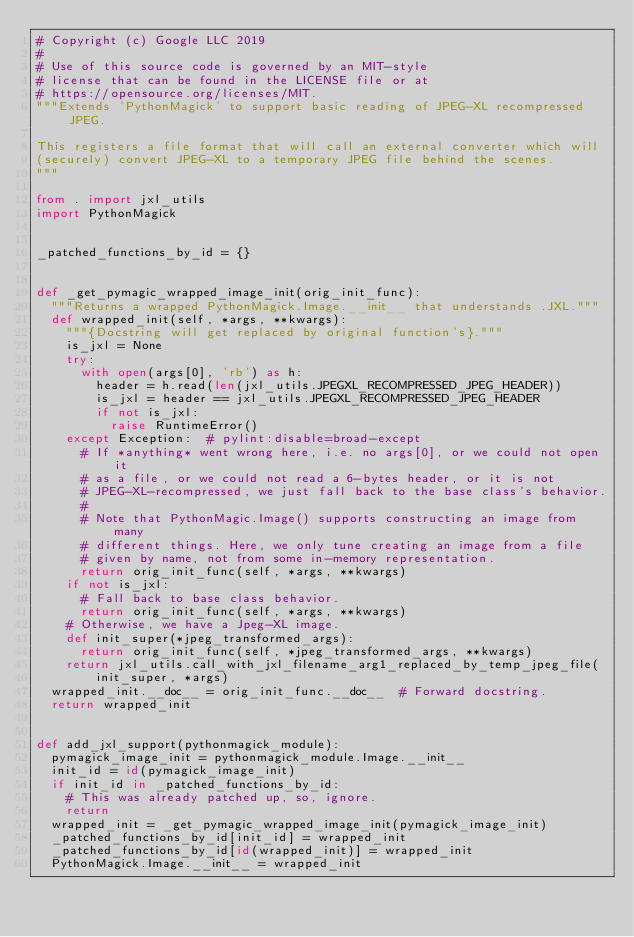Convert code to text. <code><loc_0><loc_0><loc_500><loc_500><_Python_># Copyright (c) Google LLC 2019
#
# Use of this source code is governed by an MIT-style
# license that can be found in the LICENSE file or at
# https://opensource.org/licenses/MIT.
"""Extends 'PythonMagick' to support basic reading of JPEG-XL recompressed JPEG.

This registers a file format that will call an external converter which will
(securely) convert JPEG-XL to a temporary JPEG file behind the scenes.
"""

from . import jxl_utils
import PythonMagick


_patched_functions_by_id = {}


def _get_pymagic_wrapped_image_init(orig_init_func):
  """Returns a wrapped PythonMagick.Image.__init__ that understands .JXL."""
  def wrapped_init(self, *args, **kwargs):
    """{Docstring will get replaced by original function's}."""
    is_jxl = None
    try:
      with open(args[0], 'rb') as h:
        header = h.read(len(jxl_utils.JPEGXL_RECOMPRESSED_JPEG_HEADER))
        is_jxl = header == jxl_utils.JPEGXL_RECOMPRESSED_JPEG_HEADER
        if not is_jxl:
          raise RuntimeError()
    except Exception:  # pylint:disable=broad-except
      # If *anything* went wrong here, i.e. no args[0], or we could not open it
      # as a file, or we could not read a 6-bytes header, or it is not
      # JPEG-XL-recompressed, we just fall back to the base class's behavior.
      #
      # Note that PythonMagic.Image() supports constructing an image from many
      # different things. Here, we only tune creating an image from a file
      # given by name, not from some in-memory representation.
      return orig_init_func(self, *args, **kwargs)
    if not is_jxl:
      # Fall back to base class behavior.
      return orig_init_func(self, *args, **kwargs)
    # Otherwise, we have a Jpeg-XL image.
    def init_super(*jpeg_transformed_args):
      return orig_init_func(self, *jpeg_transformed_args, **kwargs)
    return jxl_utils.call_with_jxl_filename_arg1_replaced_by_temp_jpeg_file(
        init_super, *args)
  wrapped_init.__doc__ = orig_init_func.__doc__  # Forward docstring.
  return wrapped_init


def add_jxl_support(pythonmagick_module):
  pymagick_image_init = pythonmagick_module.Image.__init__
  init_id = id(pymagick_image_init)
  if init_id in _patched_functions_by_id:
    # This was already patched up, so, ignore.
    return
  wrapped_init = _get_pymagic_wrapped_image_init(pymagick_image_init)
  _patched_functions_by_id[init_id] = wrapped_init
  _patched_functions_by_id[id(wrapped_init)] = wrapped_init
  PythonMagick.Image.__init__ = wrapped_init
</code> 